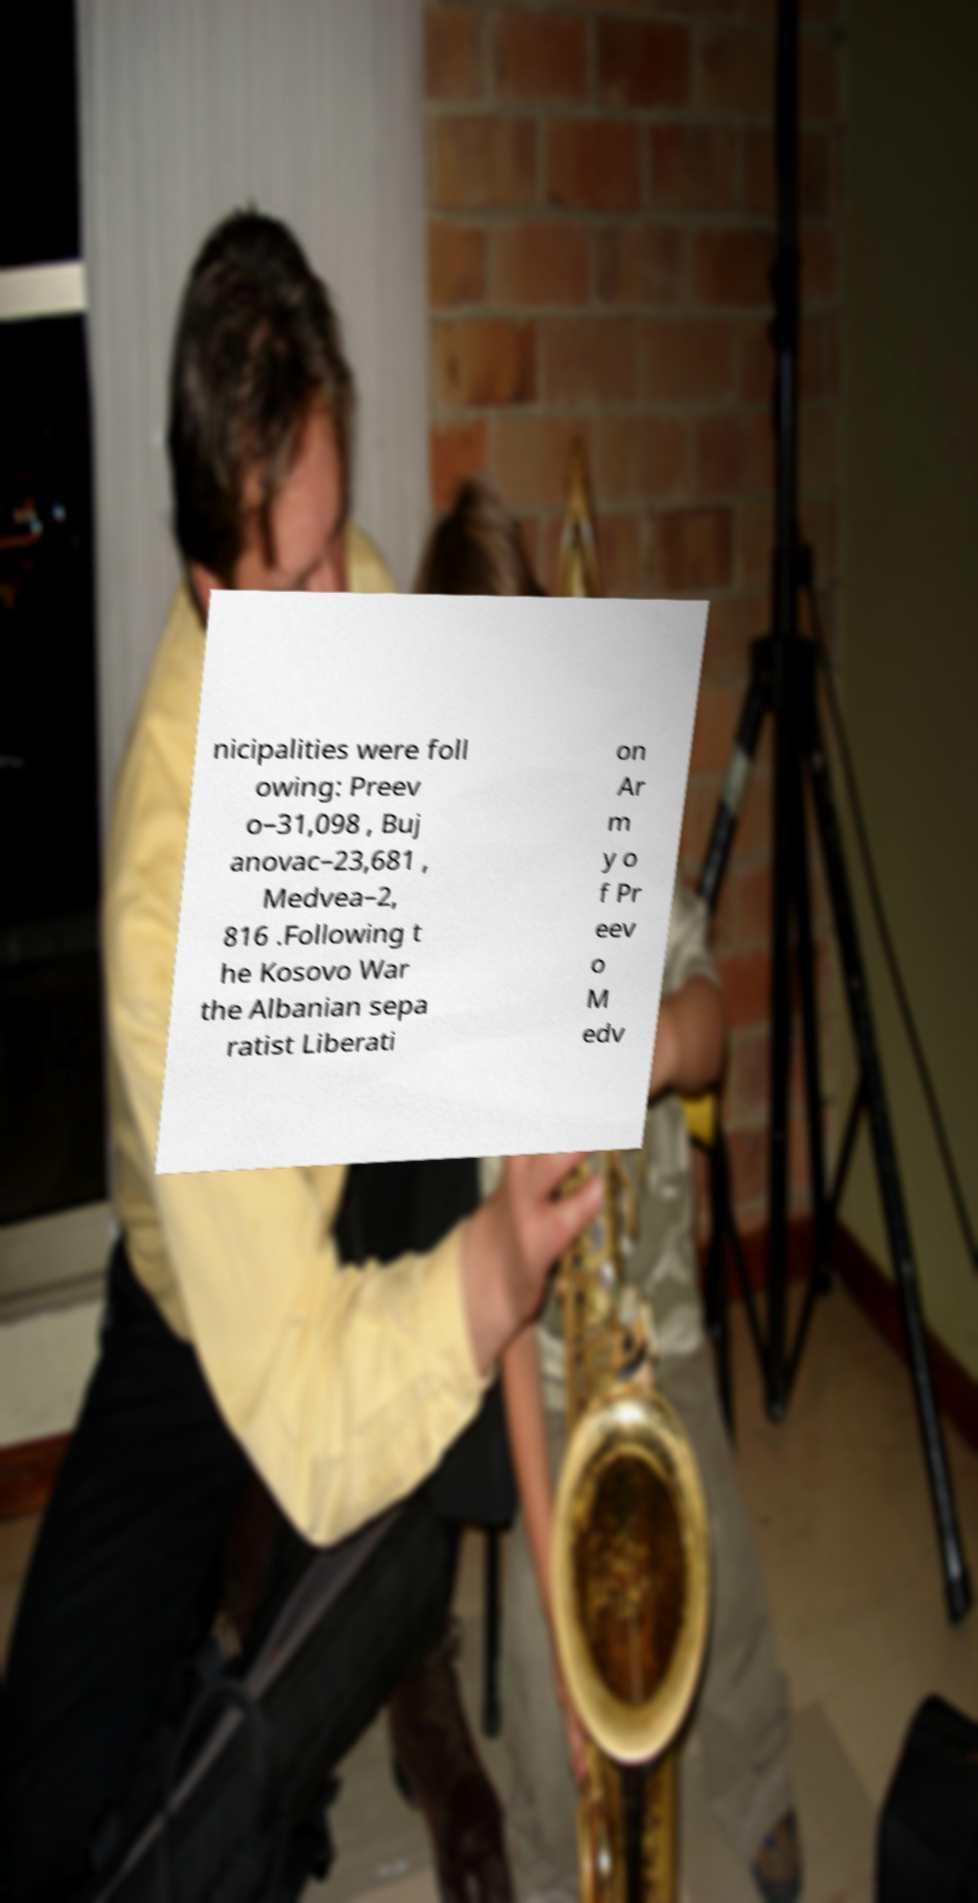Can you accurately transcribe the text from the provided image for me? nicipalities were foll owing: Preev o–31,098 , Buj anovac–23,681 , Medvea–2, 816 .Following t he Kosovo War the Albanian sepa ratist Liberati on Ar m y o f Pr eev o M edv 